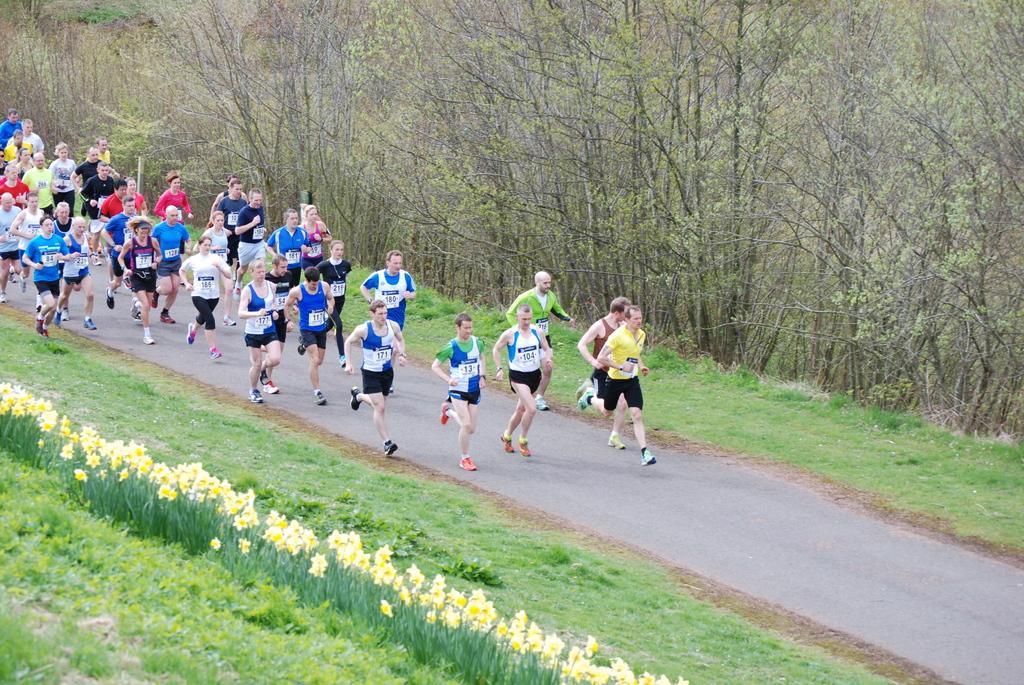In one or two sentences, can you explain what this image depicts? In this image there are group of people running on the road , there is grass, plants with flowers, and in the background there are trees. 